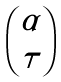Convert formula to latex. <formula><loc_0><loc_0><loc_500><loc_500>\begin{pmatrix} \alpha \\ \tau \end{pmatrix}</formula> 